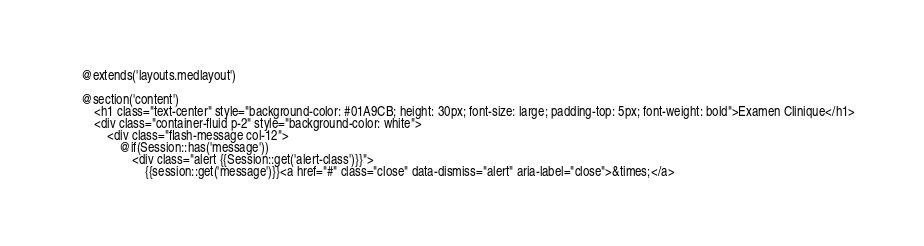<code> <loc_0><loc_0><loc_500><loc_500><_PHP_>@extends('layouts.medlayout')

@section('content')
    <h1 class="text-center" style="background-color: #01A9CB; height: 30px; font-size: large; padding-top: 5px; font-weight: bold">Examen Clinique</h1>
    <div class="container-fluid p-2" style="background-color: white">
        <div class="flash-message col-12">
            @if(Session::has('message'))
                <div class="alert {{Session::get('alert-class')}}">
                    {{session::get('message')}}<a href="#" class="close" data-dismiss="alert" aria-label="close">&times;</a></code> 